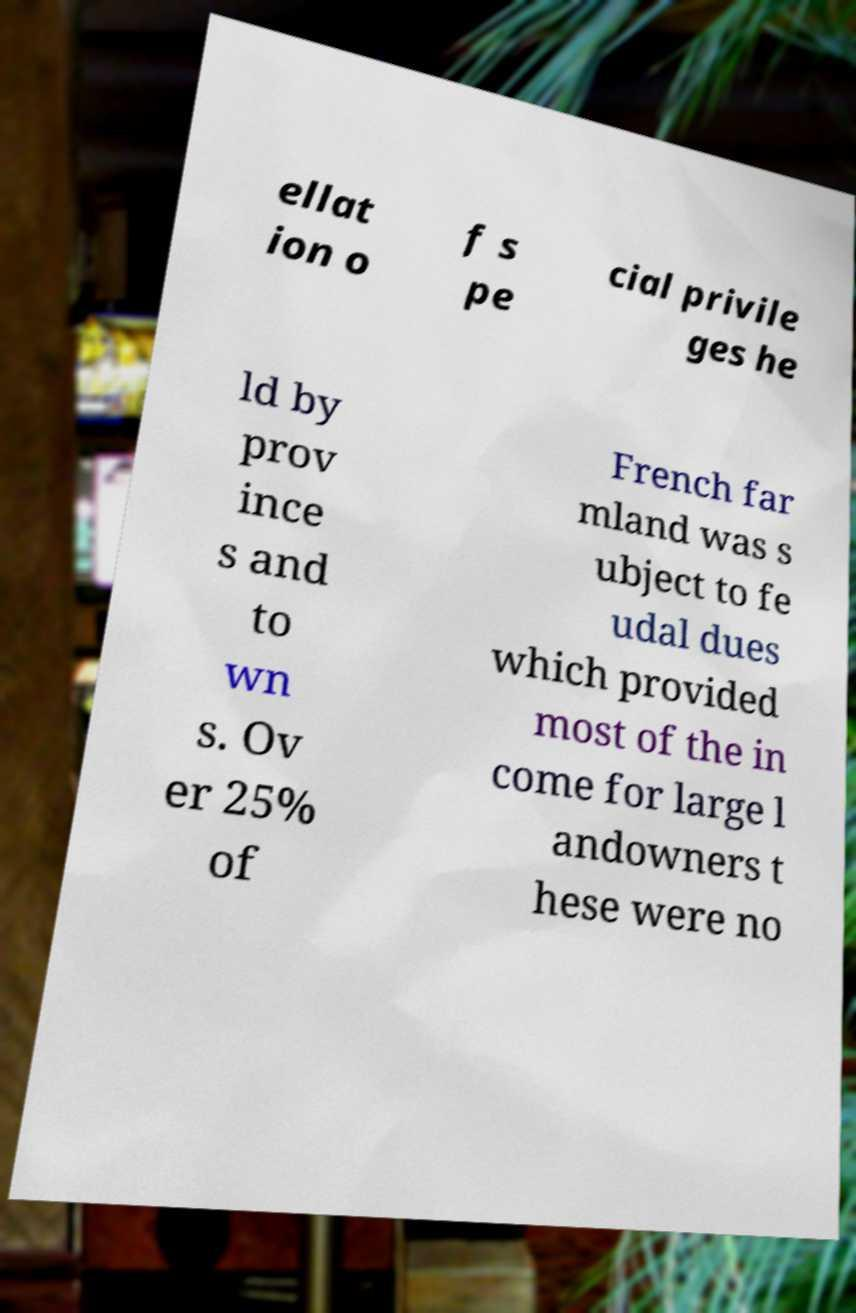For documentation purposes, I need the text within this image transcribed. Could you provide that? ellat ion o f s pe cial privile ges he ld by prov ince s and to wn s. Ov er 25% of French far mland was s ubject to fe udal dues which provided most of the in come for large l andowners t hese were no 